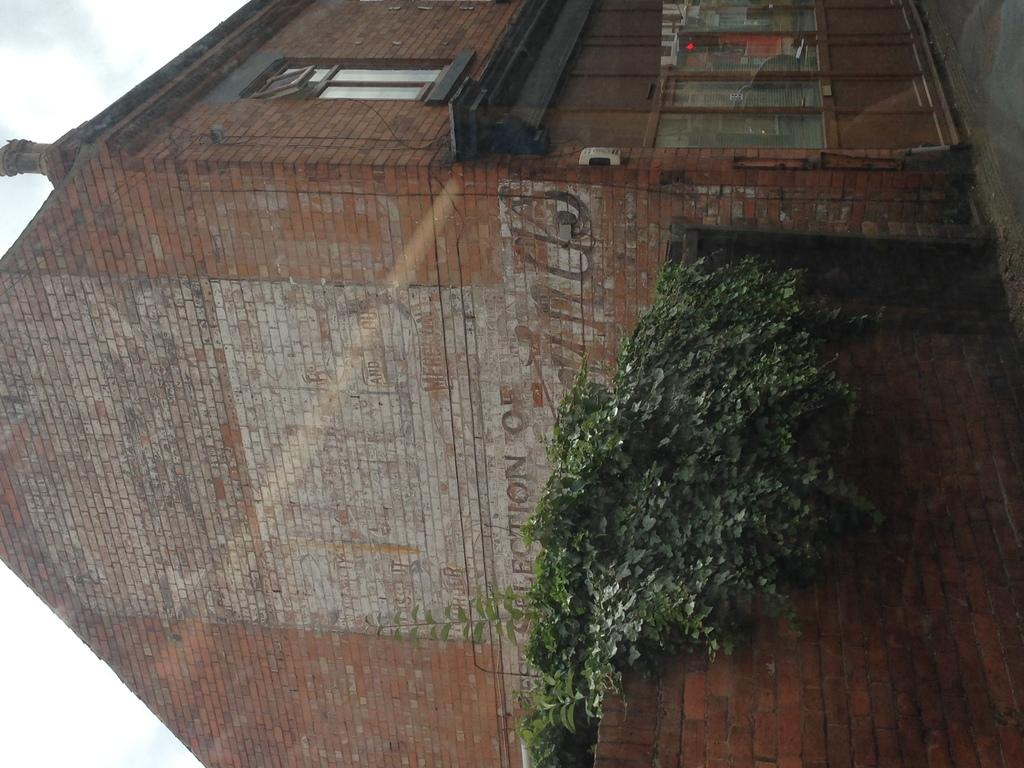What type of structure is present in the image? There is a building in the image. What feature can be seen on the building? The building has windows. What else is visible in the image besides the building? There is a wall and plants in the image. What can be seen in the background of the image? The sky is visible in the background of the image. Can you see a kite flying in the sky in the image? There is no kite visible in the sky in the image. Is there a crook standing near the building in the image? There is no crook present in the image. 